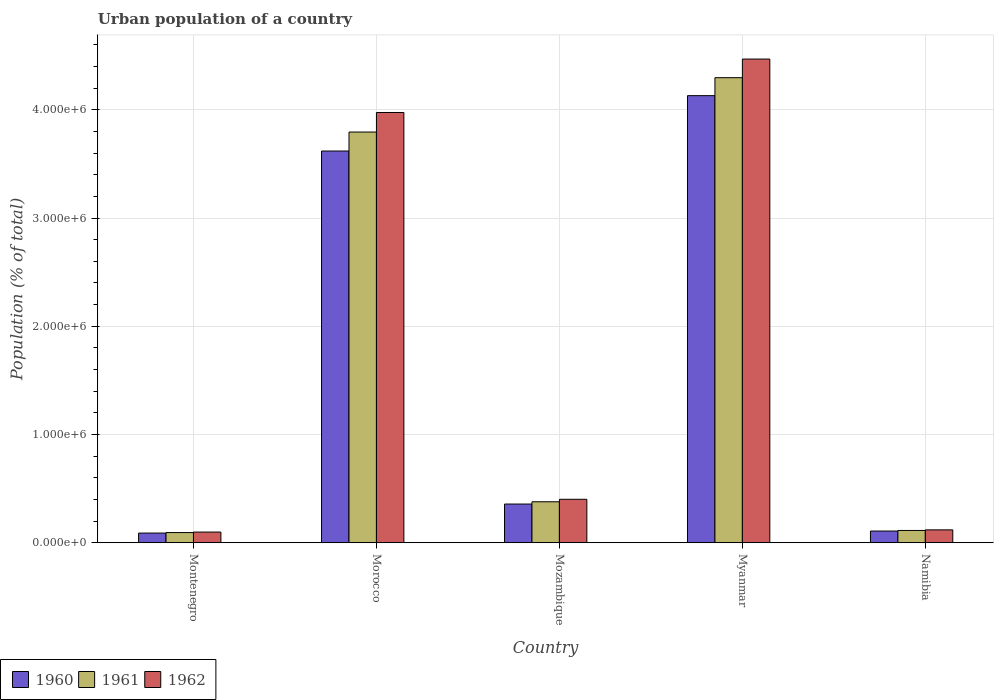Are the number of bars per tick equal to the number of legend labels?
Your response must be concise. Yes. How many bars are there on the 4th tick from the left?
Your answer should be very brief. 3. How many bars are there on the 2nd tick from the right?
Your response must be concise. 3. What is the label of the 1st group of bars from the left?
Your answer should be compact. Montenegro. What is the urban population in 1960 in Myanmar?
Ensure brevity in your answer.  4.13e+06. Across all countries, what is the maximum urban population in 1960?
Give a very brief answer. 4.13e+06. Across all countries, what is the minimum urban population in 1961?
Your response must be concise. 9.37e+04. In which country was the urban population in 1961 maximum?
Provide a short and direct response. Myanmar. In which country was the urban population in 1961 minimum?
Your response must be concise. Montenegro. What is the total urban population in 1962 in the graph?
Ensure brevity in your answer.  9.06e+06. What is the difference between the urban population in 1961 in Montenegro and that in Myanmar?
Keep it short and to the point. -4.20e+06. What is the difference between the urban population in 1960 in Namibia and the urban population in 1962 in Morocco?
Give a very brief answer. -3.87e+06. What is the average urban population in 1961 per country?
Offer a terse response. 1.74e+06. What is the difference between the urban population of/in 1961 and urban population of/in 1962 in Montenegro?
Make the answer very short. -4690. In how many countries, is the urban population in 1962 greater than 2600000 %?
Provide a succinct answer. 2. What is the ratio of the urban population in 1960 in Morocco to that in Myanmar?
Keep it short and to the point. 0.88. Is the urban population in 1960 in Mozambique less than that in Namibia?
Your answer should be very brief. No. Is the difference between the urban population in 1961 in Morocco and Mozambique greater than the difference between the urban population in 1962 in Morocco and Mozambique?
Provide a succinct answer. No. What is the difference between the highest and the second highest urban population in 1961?
Provide a succinct answer. -3.42e+06. What is the difference between the highest and the lowest urban population in 1962?
Provide a short and direct response. 4.37e+06. What does the 3rd bar from the left in Namibia represents?
Make the answer very short. 1962. What does the 3rd bar from the right in Morocco represents?
Make the answer very short. 1960. How many bars are there?
Make the answer very short. 15. Are the values on the major ticks of Y-axis written in scientific E-notation?
Give a very brief answer. Yes. Does the graph contain any zero values?
Offer a very short reply. No. Where does the legend appear in the graph?
Give a very brief answer. Bottom left. How are the legend labels stacked?
Offer a very short reply. Horizontal. What is the title of the graph?
Make the answer very short. Urban population of a country. Does "2009" appear as one of the legend labels in the graph?
Ensure brevity in your answer.  No. What is the label or title of the X-axis?
Make the answer very short. Country. What is the label or title of the Y-axis?
Keep it short and to the point. Population (% of total). What is the Population (% of total) in 1960 in Montenegro?
Your response must be concise. 8.91e+04. What is the Population (% of total) in 1961 in Montenegro?
Offer a terse response. 9.37e+04. What is the Population (% of total) in 1962 in Montenegro?
Offer a terse response. 9.84e+04. What is the Population (% of total) in 1960 in Morocco?
Offer a terse response. 3.62e+06. What is the Population (% of total) of 1961 in Morocco?
Offer a terse response. 3.79e+06. What is the Population (% of total) in 1962 in Morocco?
Your response must be concise. 3.98e+06. What is the Population (% of total) of 1960 in Mozambique?
Make the answer very short. 3.57e+05. What is the Population (% of total) of 1961 in Mozambique?
Give a very brief answer. 3.78e+05. What is the Population (% of total) of 1962 in Mozambique?
Keep it short and to the point. 4.01e+05. What is the Population (% of total) in 1960 in Myanmar?
Ensure brevity in your answer.  4.13e+06. What is the Population (% of total) of 1961 in Myanmar?
Keep it short and to the point. 4.30e+06. What is the Population (% of total) of 1962 in Myanmar?
Make the answer very short. 4.47e+06. What is the Population (% of total) in 1960 in Namibia?
Give a very brief answer. 1.08e+05. What is the Population (% of total) in 1961 in Namibia?
Ensure brevity in your answer.  1.13e+05. What is the Population (% of total) in 1962 in Namibia?
Provide a succinct answer. 1.19e+05. Across all countries, what is the maximum Population (% of total) in 1960?
Your answer should be very brief. 4.13e+06. Across all countries, what is the maximum Population (% of total) of 1961?
Offer a very short reply. 4.30e+06. Across all countries, what is the maximum Population (% of total) of 1962?
Offer a terse response. 4.47e+06. Across all countries, what is the minimum Population (% of total) in 1960?
Offer a very short reply. 8.91e+04. Across all countries, what is the minimum Population (% of total) of 1961?
Your answer should be compact. 9.37e+04. Across all countries, what is the minimum Population (% of total) in 1962?
Your response must be concise. 9.84e+04. What is the total Population (% of total) in 1960 in the graph?
Give a very brief answer. 8.30e+06. What is the total Population (% of total) of 1961 in the graph?
Provide a short and direct response. 8.68e+06. What is the total Population (% of total) of 1962 in the graph?
Provide a succinct answer. 9.06e+06. What is the difference between the Population (% of total) of 1960 in Montenegro and that in Morocco?
Your answer should be compact. -3.53e+06. What is the difference between the Population (% of total) in 1961 in Montenegro and that in Morocco?
Provide a short and direct response. -3.70e+06. What is the difference between the Population (% of total) in 1962 in Montenegro and that in Morocco?
Your answer should be very brief. -3.88e+06. What is the difference between the Population (% of total) of 1960 in Montenegro and that in Mozambique?
Ensure brevity in your answer.  -2.68e+05. What is the difference between the Population (% of total) of 1961 in Montenegro and that in Mozambique?
Give a very brief answer. -2.85e+05. What is the difference between the Population (% of total) of 1962 in Montenegro and that in Mozambique?
Make the answer very short. -3.03e+05. What is the difference between the Population (% of total) in 1960 in Montenegro and that in Myanmar?
Offer a terse response. -4.04e+06. What is the difference between the Population (% of total) of 1961 in Montenegro and that in Myanmar?
Provide a short and direct response. -4.20e+06. What is the difference between the Population (% of total) of 1962 in Montenegro and that in Myanmar?
Ensure brevity in your answer.  -4.37e+06. What is the difference between the Population (% of total) of 1960 in Montenegro and that in Namibia?
Keep it short and to the point. -1.88e+04. What is the difference between the Population (% of total) of 1961 in Montenegro and that in Namibia?
Your response must be concise. -1.95e+04. What is the difference between the Population (% of total) of 1962 in Montenegro and that in Namibia?
Give a very brief answer. -2.02e+04. What is the difference between the Population (% of total) of 1960 in Morocco and that in Mozambique?
Your answer should be very brief. 3.26e+06. What is the difference between the Population (% of total) of 1961 in Morocco and that in Mozambique?
Make the answer very short. 3.42e+06. What is the difference between the Population (% of total) in 1962 in Morocco and that in Mozambique?
Provide a succinct answer. 3.57e+06. What is the difference between the Population (% of total) of 1960 in Morocco and that in Myanmar?
Provide a succinct answer. -5.12e+05. What is the difference between the Population (% of total) in 1961 in Morocco and that in Myanmar?
Offer a terse response. -5.02e+05. What is the difference between the Population (% of total) in 1962 in Morocco and that in Myanmar?
Ensure brevity in your answer.  -4.94e+05. What is the difference between the Population (% of total) of 1960 in Morocco and that in Namibia?
Ensure brevity in your answer.  3.51e+06. What is the difference between the Population (% of total) in 1961 in Morocco and that in Namibia?
Provide a succinct answer. 3.68e+06. What is the difference between the Population (% of total) of 1962 in Morocco and that in Namibia?
Make the answer very short. 3.86e+06. What is the difference between the Population (% of total) in 1960 in Mozambique and that in Myanmar?
Make the answer very short. -3.77e+06. What is the difference between the Population (% of total) in 1961 in Mozambique and that in Myanmar?
Give a very brief answer. -3.92e+06. What is the difference between the Population (% of total) of 1962 in Mozambique and that in Myanmar?
Make the answer very short. -4.07e+06. What is the difference between the Population (% of total) of 1960 in Mozambique and that in Namibia?
Give a very brief answer. 2.49e+05. What is the difference between the Population (% of total) of 1961 in Mozambique and that in Namibia?
Make the answer very short. 2.65e+05. What is the difference between the Population (% of total) of 1962 in Mozambique and that in Namibia?
Offer a very short reply. 2.83e+05. What is the difference between the Population (% of total) in 1960 in Myanmar and that in Namibia?
Provide a succinct answer. 4.02e+06. What is the difference between the Population (% of total) of 1961 in Myanmar and that in Namibia?
Your answer should be very brief. 4.18e+06. What is the difference between the Population (% of total) in 1962 in Myanmar and that in Namibia?
Offer a terse response. 4.35e+06. What is the difference between the Population (% of total) in 1960 in Montenegro and the Population (% of total) in 1961 in Morocco?
Provide a short and direct response. -3.71e+06. What is the difference between the Population (% of total) of 1960 in Montenegro and the Population (% of total) of 1962 in Morocco?
Provide a succinct answer. -3.89e+06. What is the difference between the Population (% of total) in 1961 in Montenegro and the Population (% of total) in 1962 in Morocco?
Your response must be concise. -3.88e+06. What is the difference between the Population (% of total) in 1960 in Montenegro and the Population (% of total) in 1961 in Mozambique?
Your answer should be very brief. -2.89e+05. What is the difference between the Population (% of total) of 1960 in Montenegro and the Population (% of total) of 1962 in Mozambique?
Your answer should be compact. -3.12e+05. What is the difference between the Population (% of total) in 1961 in Montenegro and the Population (% of total) in 1962 in Mozambique?
Keep it short and to the point. -3.08e+05. What is the difference between the Population (% of total) in 1960 in Montenegro and the Population (% of total) in 1961 in Myanmar?
Your answer should be very brief. -4.21e+06. What is the difference between the Population (% of total) of 1960 in Montenegro and the Population (% of total) of 1962 in Myanmar?
Provide a short and direct response. -4.38e+06. What is the difference between the Population (% of total) in 1961 in Montenegro and the Population (% of total) in 1962 in Myanmar?
Your answer should be compact. -4.38e+06. What is the difference between the Population (% of total) in 1960 in Montenegro and the Population (% of total) in 1961 in Namibia?
Make the answer very short. -2.41e+04. What is the difference between the Population (% of total) in 1960 in Montenegro and the Population (% of total) in 1962 in Namibia?
Provide a short and direct response. -2.95e+04. What is the difference between the Population (% of total) in 1961 in Montenegro and the Population (% of total) in 1962 in Namibia?
Your answer should be compact. -2.49e+04. What is the difference between the Population (% of total) of 1960 in Morocco and the Population (% of total) of 1961 in Mozambique?
Offer a very short reply. 3.24e+06. What is the difference between the Population (% of total) of 1960 in Morocco and the Population (% of total) of 1962 in Mozambique?
Offer a terse response. 3.22e+06. What is the difference between the Population (% of total) in 1961 in Morocco and the Population (% of total) in 1962 in Mozambique?
Offer a terse response. 3.39e+06. What is the difference between the Population (% of total) of 1960 in Morocco and the Population (% of total) of 1961 in Myanmar?
Provide a short and direct response. -6.78e+05. What is the difference between the Population (% of total) in 1960 in Morocco and the Population (% of total) in 1962 in Myanmar?
Offer a terse response. -8.50e+05. What is the difference between the Population (% of total) in 1961 in Morocco and the Population (% of total) in 1962 in Myanmar?
Provide a succinct answer. -6.74e+05. What is the difference between the Population (% of total) of 1960 in Morocco and the Population (% of total) of 1961 in Namibia?
Keep it short and to the point. 3.51e+06. What is the difference between the Population (% of total) of 1960 in Morocco and the Population (% of total) of 1962 in Namibia?
Keep it short and to the point. 3.50e+06. What is the difference between the Population (% of total) of 1961 in Morocco and the Population (% of total) of 1962 in Namibia?
Your answer should be compact. 3.68e+06. What is the difference between the Population (% of total) of 1960 in Mozambique and the Population (% of total) of 1961 in Myanmar?
Give a very brief answer. -3.94e+06. What is the difference between the Population (% of total) of 1960 in Mozambique and the Population (% of total) of 1962 in Myanmar?
Give a very brief answer. -4.11e+06. What is the difference between the Population (% of total) in 1961 in Mozambique and the Population (% of total) in 1962 in Myanmar?
Ensure brevity in your answer.  -4.09e+06. What is the difference between the Population (% of total) of 1960 in Mozambique and the Population (% of total) of 1961 in Namibia?
Offer a terse response. 2.44e+05. What is the difference between the Population (% of total) of 1960 in Mozambique and the Population (% of total) of 1962 in Namibia?
Your answer should be compact. 2.39e+05. What is the difference between the Population (% of total) of 1961 in Mozambique and the Population (% of total) of 1962 in Namibia?
Ensure brevity in your answer.  2.60e+05. What is the difference between the Population (% of total) of 1960 in Myanmar and the Population (% of total) of 1961 in Namibia?
Keep it short and to the point. 4.02e+06. What is the difference between the Population (% of total) of 1960 in Myanmar and the Population (% of total) of 1962 in Namibia?
Offer a terse response. 4.01e+06. What is the difference between the Population (% of total) in 1961 in Myanmar and the Population (% of total) in 1962 in Namibia?
Provide a succinct answer. 4.18e+06. What is the average Population (% of total) of 1960 per country?
Ensure brevity in your answer.  1.66e+06. What is the average Population (% of total) of 1961 per country?
Keep it short and to the point. 1.74e+06. What is the average Population (% of total) of 1962 per country?
Your answer should be compact. 1.81e+06. What is the difference between the Population (% of total) of 1960 and Population (% of total) of 1961 in Montenegro?
Provide a succinct answer. -4587. What is the difference between the Population (% of total) in 1960 and Population (% of total) in 1962 in Montenegro?
Give a very brief answer. -9277. What is the difference between the Population (% of total) in 1961 and Population (% of total) in 1962 in Montenegro?
Provide a succinct answer. -4690. What is the difference between the Population (% of total) of 1960 and Population (% of total) of 1961 in Morocco?
Provide a succinct answer. -1.75e+05. What is the difference between the Population (% of total) in 1960 and Population (% of total) in 1962 in Morocco?
Provide a succinct answer. -3.56e+05. What is the difference between the Population (% of total) in 1961 and Population (% of total) in 1962 in Morocco?
Give a very brief answer. -1.81e+05. What is the difference between the Population (% of total) in 1960 and Population (% of total) in 1961 in Mozambique?
Provide a succinct answer. -2.09e+04. What is the difference between the Population (% of total) of 1960 and Population (% of total) of 1962 in Mozambique?
Give a very brief answer. -4.38e+04. What is the difference between the Population (% of total) of 1961 and Population (% of total) of 1962 in Mozambique?
Offer a terse response. -2.29e+04. What is the difference between the Population (% of total) in 1960 and Population (% of total) in 1961 in Myanmar?
Make the answer very short. -1.66e+05. What is the difference between the Population (% of total) in 1960 and Population (% of total) in 1962 in Myanmar?
Your response must be concise. -3.38e+05. What is the difference between the Population (% of total) in 1961 and Population (% of total) in 1962 in Myanmar?
Offer a very short reply. -1.72e+05. What is the difference between the Population (% of total) in 1960 and Population (% of total) in 1961 in Namibia?
Offer a very short reply. -5262. What is the difference between the Population (% of total) in 1960 and Population (% of total) in 1962 in Namibia?
Your response must be concise. -1.07e+04. What is the difference between the Population (% of total) of 1961 and Population (% of total) of 1962 in Namibia?
Offer a terse response. -5439. What is the ratio of the Population (% of total) of 1960 in Montenegro to that in Morocco?
Offer a very short reply. 0.02. What is the ratio of the Population (% of total) of 1961 in Montenegro to that in Morocco?
Offer a very short reply. 0.02. What is the ratio of the Population (% of total) of 1962 in Montenegro to that in Morocco?
Offer a terse response. 0.02. What is the ratio of the Population (% of total) of 1960 in Montenegro to that in Mozambique?
Offer a very short reply. 0.25. What is the ratio of the Population (% of total) of 1961 in Montenegro to that in Mozambique?
Offer a terse response. 0.25. What is the ratio of the Population (% of total) in 1962 in Montenegro to that in Mozambique?
Your response must be concise. 0.25. What is the ratio of the Population (% of total) of 1960 in Montenegro to that in Myanmar?
Your answer should be compact. 0.02. What is the ratio of the Population (% of total) in 1961 in Montenegro to that in Myanmar?
Ensure brevity in your answer.  0.02. What is the ratio of the Population (% of total) in 1962 in Montenegro to that in Myanmar?
Offer a very short reply. 0.02. What is the ratio of the Population (% of total) of 1960 in Montenegro to that in Namibia?
Offer a terse response. 0.83. What is the ratio of the Population (% of total) in 1961 in Montenegro to that in Namibia?
Offer a terse response. 0.83. What is the ratio of the Population (% of total) in 1962 in Montenegro to that in Namibia?
Your answer should be very brief. 0.83. What is the ratio of the Population (% of total) in 1960 in Morocco to that in Mozambique?
Your answer should be compact. 10.13. What is the ratio of the Population (% of total) of 1961 in Morocco to that in Mozambique?
Offer a very short reply. 10.03. What is the ratio of the Population (% of total) of 1962 in Morocco to that in Mozambique?
Ensure brevity in your answer.  9.91. What is the ratio of the Population (% of total) of 1960 in Morocco to that in Myanmar?
Keep it short and to the point. 0.88. What is the ratio of the Population (% of total) of 1961 in Morocco to that in Myanmar?
Offer a very short reply. 0.88. What is the ratio of the Population (% of total) in 1962 in Morocco to that in Myanmar?
Offer a terse response. 0.89. What is the ratio of the Population (% of total) in 1960 in Morocco to that in Namibia?
Keep it short and to the point. 33.54. What is the ratio of the Population (% of total) in 1961 in Morocco to that in Namibia?
Provide a succinct answer. 33.53. What is the ratio of the Population (% of total) of 1962 in Morocco to that in Namibia?
Offer a very short reply. 33.52. What is the ratio of the Population (% of total) in 1960 in Mozambique to that in Myanmar?
Your response must be concise. 0.09. What is the ratio of the Population (% of total) in 1961 in Mozambique to that in Myanmar?
Keep it short and to the point. 0.09. What is the ratio of the Population (% of total) in 1962 in Mozambique to that in Myanmar?
Make the answer very short. 0.09. What is the ratio of the Population (% of total) in 1960 in Mozambique to that in Namibia?
Offer a very short reply. 3.31. What is the ratio of the Population (% of total) of 1961 in Mozambique to that in Namibia?
Offer a terse response. 3.34. What is the ratio of the Population (% of total) of 1962 in Mozambique to that in Namibia?
Make the answer very short. 3.38. What is the ratio of the Population (% of total) in 1960 in Myanmar to that in Namibia?
Your answer should be very brief. 38.28. What is the ratio of the Population (% of total) of 1961 in Myanmar to that in Namibia?
Offer a terse response. 37.97. What is the ratio of the Population (% of total) of 1962 in Myanmar to that in Namibia?
Offer a very short reply. 37.68. What is the difference between the highest and the second highest Population (% of total) in 1960?
Your response must be concise. 5.12e+05. What is the difference between the highest and the second highest Population (% of total) in 1961?
Give a very brief answer. 5.02e+05. What is the difference between the highest and the second highest Population (% of total) in 1962?
Make the answer very short. 4.94e+05. What is the difference between the highest and the lowest Population (% of total) of 1960?
Offer a terse response. 4.04e+06. What is the difference between the highest and the lowest Population (% of total) in 1961?
Provide a short and direct response. 4.20e+06. What is the difference between the highest and the lowest Population (% of total) in 1962?
Provide a short and direct response. 4.37e+06. 